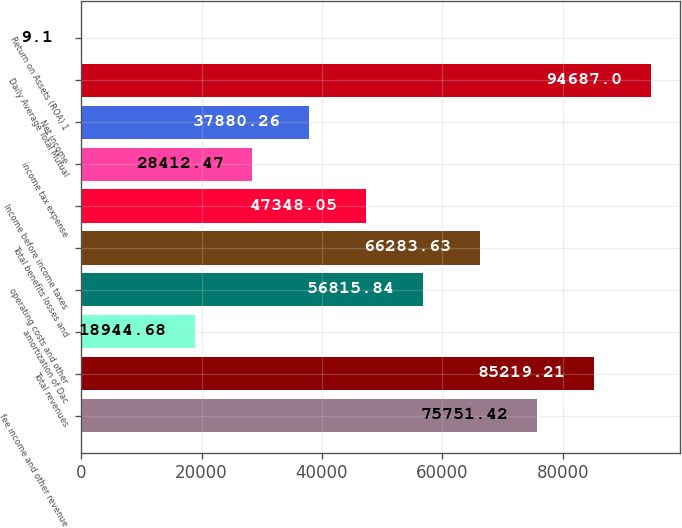Convert chart. <chart><loc_0><loc_0><loc_500><loc_500><bar_chart><fcel>fee income and other revenue<fcel>Total revenues<fcel>amortization of Dac<fcel>operating costs and other<fcel>Total benefits losses and<fcel>Income before income taxes<fcel>income tax expense<fcel>Net income<fcel>Daily Average Total Mutual<fcel>Return on Assets (ROA) 1<nl><fcel>75751.4<fcel>85219.2<fcel>18944.7<fcel>56815.8<fcel>66283.6<fcel>47348.1<fcel>28412.5<fcel>37880.3<fcel>94687<fcel>9.1<nl></chart> 